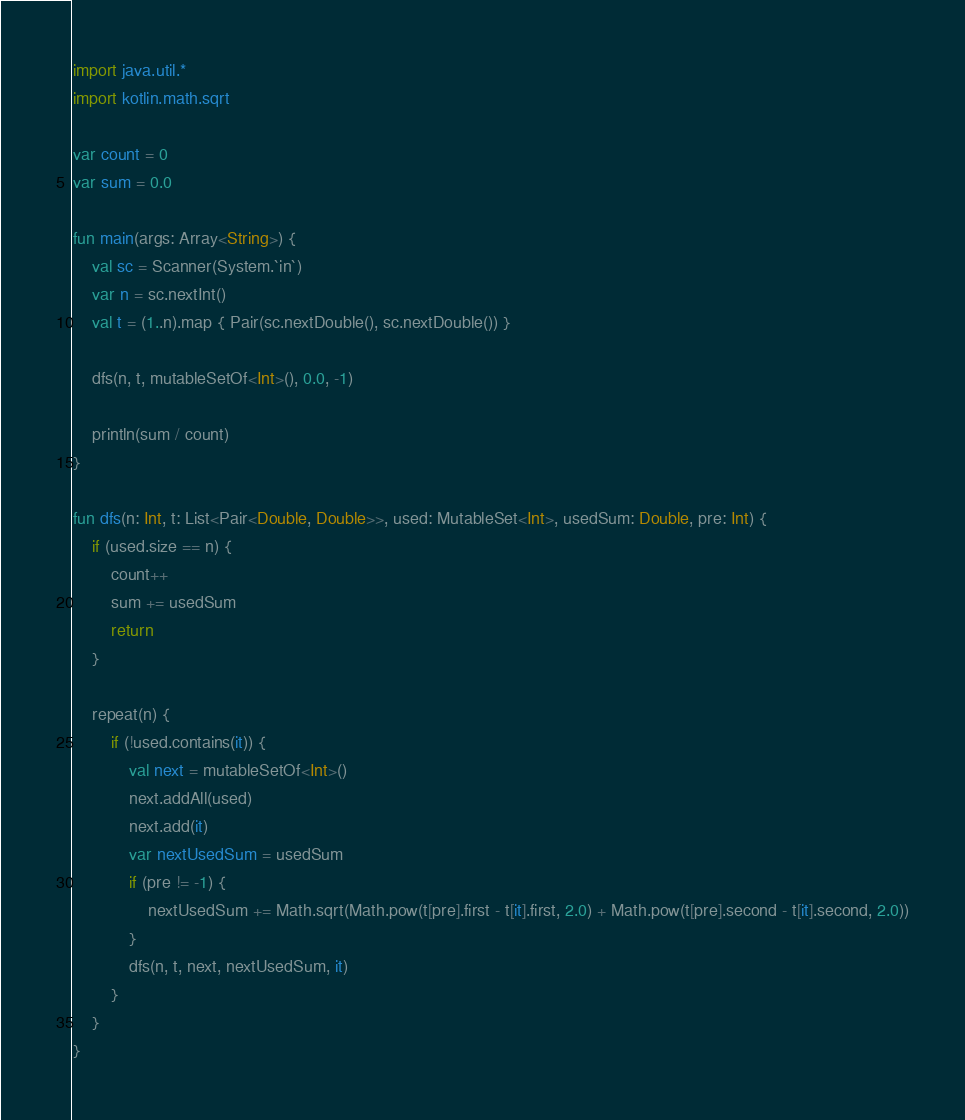<code> <loc_0><loc_0><loc_500><loc_500><_Kotlin_>import java.util.*
import kotlin.math.sqrt

var count = 0
var sum = 0.0

fun main(args: Array<String>) {
    val sc = Scanner(System.`in`)
    var n = sc.nextInt()
    val t = (1..n).map { Pair(sc.nextDouble(), sc.nextDouble()) }

    dfs(n, t, mutableSetOf<Int>(), 0.0, -1)

    println(sum / count)
}

fun dfs(n: Int, t: List<Pair<Double, Double>>, used: MutableSet<Int>, usedSum: Double, pre: Int) {
    if (used.size == n) {
        count++
        sum += usedSum
        return
    }

    repeat(n) {
        if (!used.contains(it)) {
            val next = mutableSetOf<Int>()
            next.addAll(used)
            next.add(it)
            var nextUsedSum = usedSum
            if (pre != -1) {
                nextUsedSum += Math.sqrt(Math.pow(t[pre].first - t[it].first, 2.0) + Math.pow(t[pre].second - t[it].second, 2.0))
            }
            dfs(n, t, next, nextUsedSum, it)
        }
    }
}
</code> 